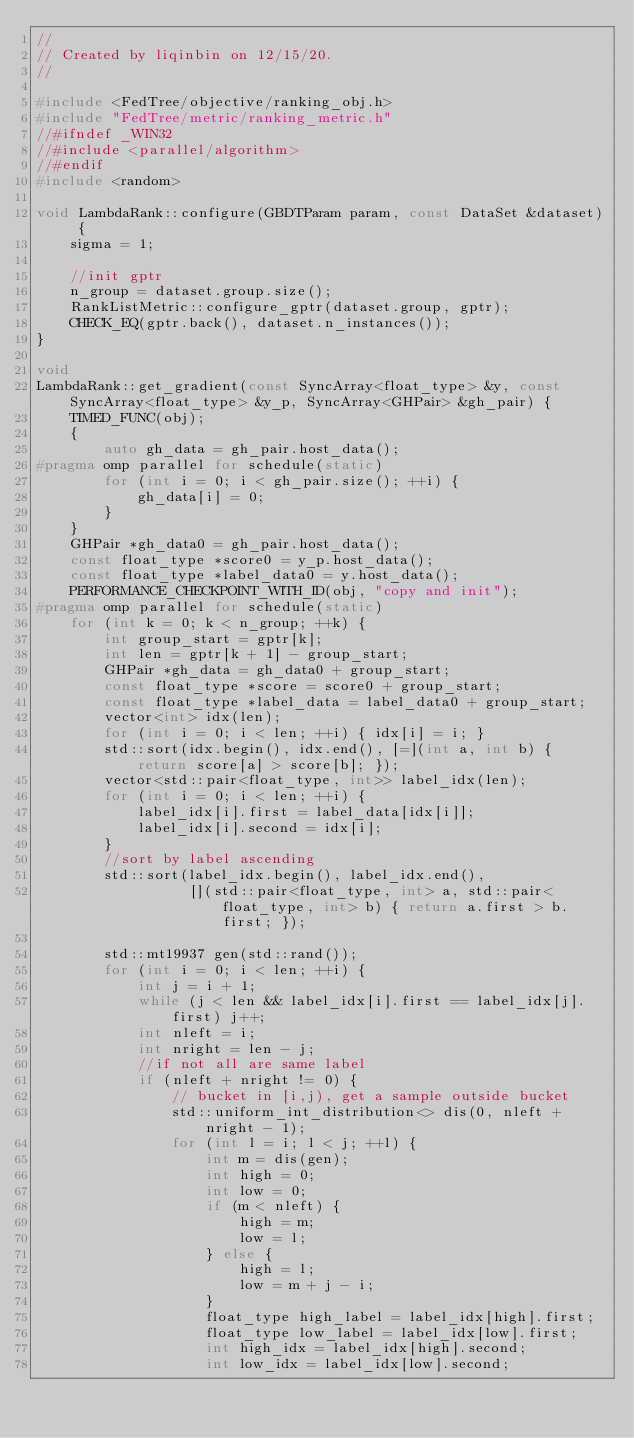<code> <loc_0><loc_0><loc_500><loc_500><_C++_>//
// Created by liqinbin on 12/15/20.
//

#include <FedTree/objective/ranking_obj.h>
#include "FedTree/metric/ranking_metric.h"
//#ifndef _WIN32
//#include <parallel/algorithm>
//#endif
#include <random>

void LambdaRank::configure(GBDTParam param, const DataSet &dataset) {
    sigma = 1;

    //init gptr
    n_group = dataset.group.size();
    RankListMetric::configure_gptr(dataset.group, gptr);
    CHECK_EQ(gptr.back(), dataset.n_instances());
}

void
LambdaRank::get_gradient(const SyncArray<float_type> &y, const SyncArray<float_type> &y_p, SyncArray<GHPair> &gh_pair) {
    TIMED_FUNC(obj);
    {
        auto gh_data = gh_pair.host_data();
#pragma omp parallel for schedule(static)
        for (int i = 0; i < gh_pair.size(); ++i) {
            gh_data[i] = 0;
        }
    }
    GHPair *gh_data0 = gh_pair.host_data();
    const float_type *score0 = y_p.host_data();
    const float_type *label_data0 = y.host_data();
    PERFORMANCE_CHECKPOINT_WITH_ID(obj, "copy and init");
#pragma omp parallel for schedule(static)
    for (int k = 0; k < n_group; ++k) {
        int group_start = gptr[k];
        int len = gptr[k + 1] - group_start;
        GHPair *gh_data = gh_data0 + group_start;
        const float_type *score = score0 + group_start;
        const float_type *label_data = label_data0 + group_start;
        vector<int> idx(len);
        for (int i = 0; i < len; ++i) { idx[i] = i; }
        std::sort(idx.begin(), idx.end(), [=](int a, int b) { return score[a] > score[b]; });
        vector<std::pair<float_type, int>> label_idx(len);
        for (int i = 0; i < len; ++i) {
            label_idx[i].first = label_data[idx[i]];
            label_idx[i].second = idx[i];
        }
        //sort by label ascending
        std::sort(label_idx.begin(), label_idx.end(),
                  [](std::pair<float_type, int> a, std::pair<float_type, int> b) { return a.first > b.first; });

        std::mt19937 gen(std::rand());
        for (int i = 0; i < len; ++i) {
            int j = i + 1;
            while (j < len && label_idx[i].first == label_idx[j].first) j++;
            int nleft = i;
            int nright = len - j;
            //if not all are same label
            if (nleft + nright != 0) {
                // bucket in [i,j), get a sample outside bucket
                std::uniform_int_distribution<> dis(0, nleft + nright - 1);
                for (int l = i; l < j; ++l) {
                    int m = dis(gen);
                    int high = 0;
                    int low = 0;
                    if (m < nleft) {
                        high = m;
                        low = l;
                    } else {
                        high = l;
                        low = m + j - i;
                    }
                    float_type high_label = label_idx[high].first;
                    float_type low_label = label_idx[low].first;
                    int high_idx = label_idx[high].second;
                    int low_idx = label_idx[low].second;
</code> 